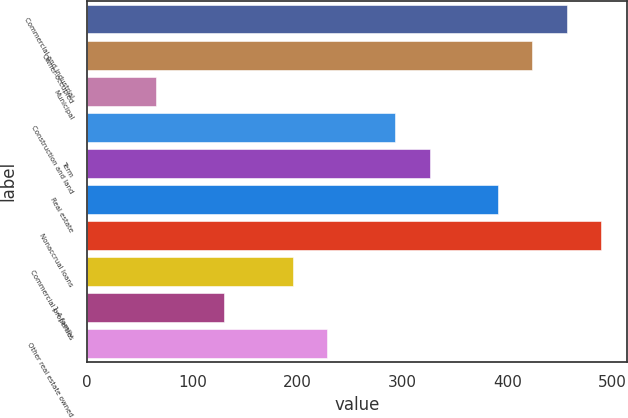Convert chart. <chart><loc_0><loc_0><loc_500><loc_500><bar_chart><fcel>Commercial and industrial<fcel>Owner-occupied<fcel>Municipal<fcel>Construction and land<fcel>Term<fcel>Real estate<fcel>Nonaccrual loans<fcel>Commercial properties<fcel>1-4 family<fcel>Other real estate owned<nl><fcel>456.33<fcel>423.74<fcel>65.25<fcel>293.38<fcel>325.97<fcel>391.15<fcel>488.92<fcel>195.61<fcel>130.43<fcel>228.2<nl></chart> 